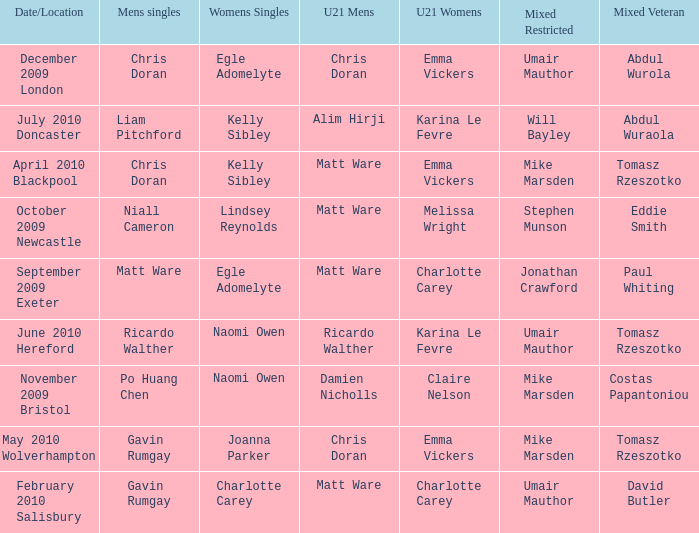When and where did Eddie Smith win the mixed veteran? 1.0. 